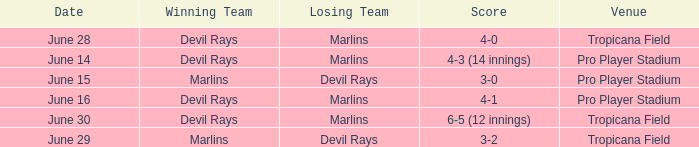What was the score on june 29 when the devil rays los? 3-2. 